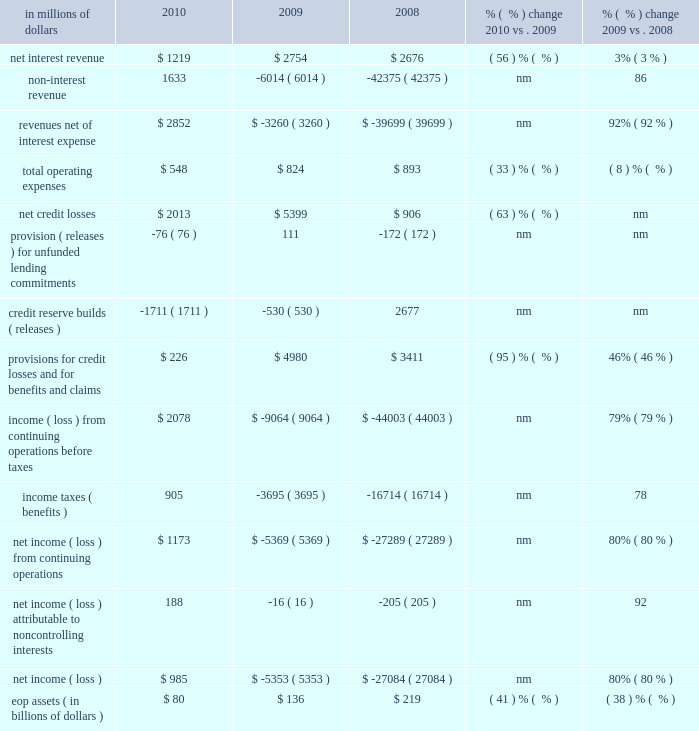Special asset pool special asset pool ( sap ) , which constituted approximately 22% ( 22 % ) of citi holdings by assets as of december 31 , 2010 , is a portfolio of securities , loans and other assets that citigroup intends to actively reduce over time through asset sales and portfolio run-off .
At december 31 , 2010 , sap had $ 80 billion of assets .
Sap assets have declined by $ 248 billion , or 76% ( 76 % ) , from peak levels in 2007 reflecting cumulative write-downs , asset sales and portfolio run-off .
In millions of dollars 2010 2009 2008 % (  % ) change 2010 vs .
2009 % (  % ) change 2009 vs .
2008 .
Nm not meaningful 2010 vs .
2009 revenues , net of interest expense increased $ 6.1 billion , primarily due to the improvement of revenue marks in 2010 .
Aggregate marks were negative $ 2.6 billion in 2009 as compared to positive marks of $ 3.4 billion in 2010 ( see 201citems impacting sap revenues 201d below ) .
Revenue in the current year included positive marks of $ 2.0 billion related to sub-prime related direct exposure , a positive $ 0.5 billion cva related to the monoline insurers , and $ 0.4 billion on private equity positions .
These positive marks were partially offset by negative revenues of $ 0.5 billion on alt-a mortgages and $ 0.4 billion on commercial real estate .
Operating expenses decreased 33% ( 33 % ) in 2010 , mainly driven by the absence of the u.s .
Government loss-sharing agreement , lower compensation , and lower transaction expenses .
Provisions for credit losses and for benefits and claims decreased $ 4.8 billion due to a decrease in net credit losses of $ 3.4 billion and a higher release of loan loss reserves and unfunded lending commitments of $ 1.4 billion .
Assets declined 41% ( 41 % ) from the prior year , primarily driven by sales and amortization and prepayments .
Asset sales of $ 39 billion for the year of 2010 generated pretax gains of approximately $ 1.3 billion .
2009 vs .
2008 revenues , net of interest expense increased $ 36.4 billion in 2009 , primarily due to the absence of significant negative revenue marks occurring in the prior year .
Total negative marks were $ 2.6 billion in 2009 as compared to $ 37.4 billion in 2008 .
Revenue in 2009 included positive marks of $ 0.8 billion on subprime-related direct exposures .
These positive revenues were partially offset by negative revenues of $ 1.5 billion on alt-a mortgages , $ 0.8 billion of write-downs on commercial real estate , and a negative $ 1.6 billion cva on the monoline insurers and fair value option liabilities .
Revenue was also affected by negative marks on private equity positions and write-downs on highly leveraged finance commitments .
Operating expenses decreased 8% ( 8 % ) in 2009 , mainly driven by lower compensation and lower volumes and transaction expenses , partially offset by costs associated with the u.s .
Government loss-sharing agreement exited in the fourth quarter of 2009 .
Provisions for credit losses and for benefits and claims increased $ 1.6 billion , primarily driven by $ 4.5 billion in increased net credit losses , partially offset by a lower provision for loan losses and unfunded lending commitments of $ 2.9 billion .
Assets declined 38% ( 38 % ) versus the prior year , primarily driven by amortization and prepayments , sales , marks and charge-offs. .
What percentage of revenue net of interest expense is due to non-interest revenue in 2010? 
Computations: (1633 / 2852)
Answer: 0.57258. 